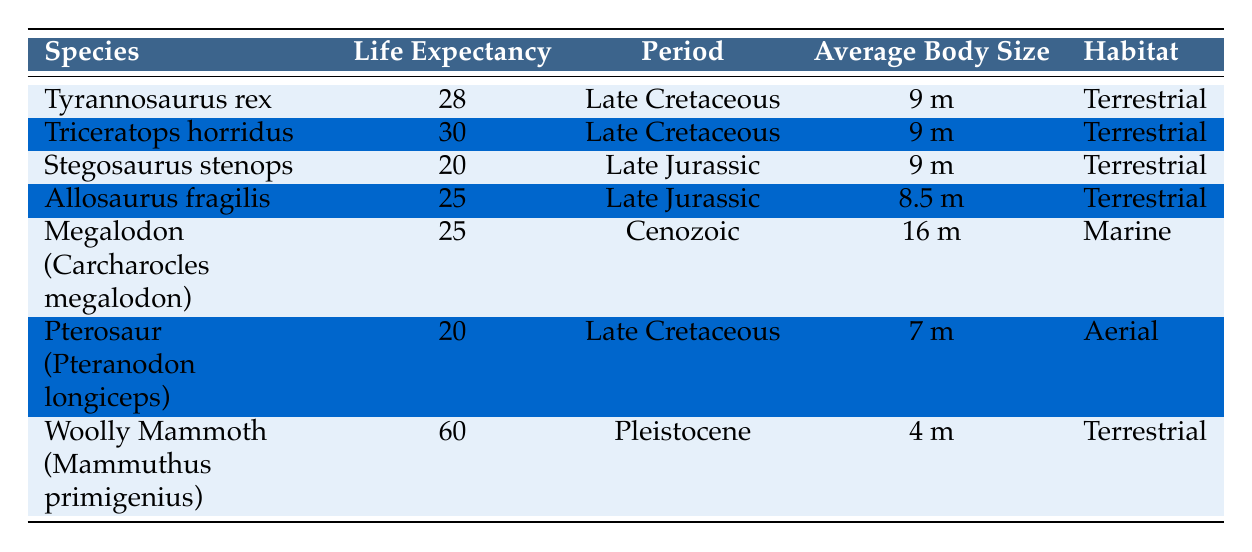What is the life expectancy of Woolly Mammoth? The table shows the life expectancy of different species, and specifically for the Woolly Mammoth (Mammuthus primigenius), the value listed is 60.
Answer: 60 Which species has the highest life expectancy? By examining the life expectancy values across all species in the table, the highest life expectancy is associated with the Woolly Mammoth, listed at 60.
Answer: Woolly Mammoth How many species have a life expectancy greater than 25 years? We can find species with life expectancy greater than 25 by filtering the data. The species with life expectancy greater than 25 are Triceratops horridus (30) and Woolly Mammoth (60), making a total of 3 species: Triceratops, Tyrannosaurus, and Woolly Mammoth.
Answer: 3 What is the average life expectancy of the species in the Late Cretaceous period? There are three species in the Late Cretaceous: Tyrannosaurus rex (28), Triceratops horridus (30), and Pterosaur (20). The average life expectancy is calculated as (28 + 30 + 20) / 3 = 26.
Answer: 26 Is the life expectancy of Allosaurus fragilis greater than or equal to 30? The life expectancy of Allosaurus fragilis is 25, which is less than 30. Therefore, the answer is no.
Answer: No Which species has a longer life expectancy, Stegosaurus stenops or Megalodon? The life expectancy of Stegosaurus stenops is 20, and that of Megalodon is 25. Since 25 is greater than 20, Megalodon has a longer life expectancy.
Answer: Megalodon How many species are categorized as terrestrial? By counting the species listed under the habitat category of Terrestrial, we find Tyrannosaurus rex, Triceratops horridus, Stegosaurus stenops, Allosaurus fragilis, and Woolly Mammoth. This totals to 5 species.
Answer: 5 What is the difference in life expectancy between the longest-living species and the shortest-living species? The longest-living species is the Woolly Mammoth with an expectancy of 60 years, and the shortest-living species are Pterosaur, Stegosaurus, and Allosaurus with an expectancy of 20 years. The difference is 60 - 20 = 40.
Answer: 40 How many species have an average body size of 9 meters? The species listed with an average body size of 9 meters are Tyrannosaurus rex, Triceratops horridus, and Stegosaurus stenops. This sums up to 3 species.
Answer: 3 